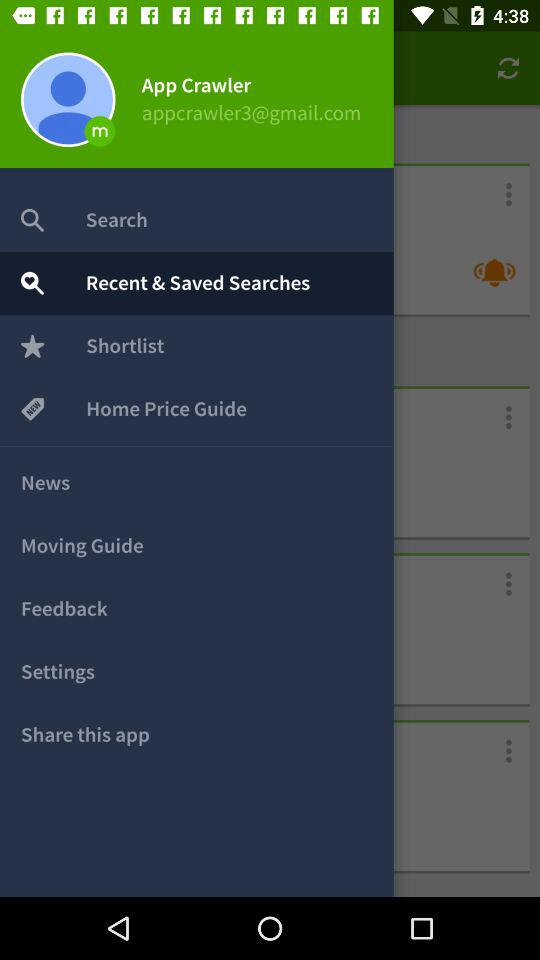What is the user name? The user name is App Crawler. 